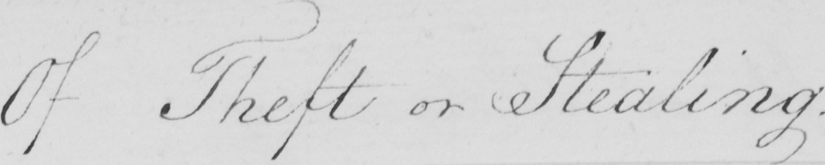What text is written in this handwritten line? Of Theft or Stealing . 